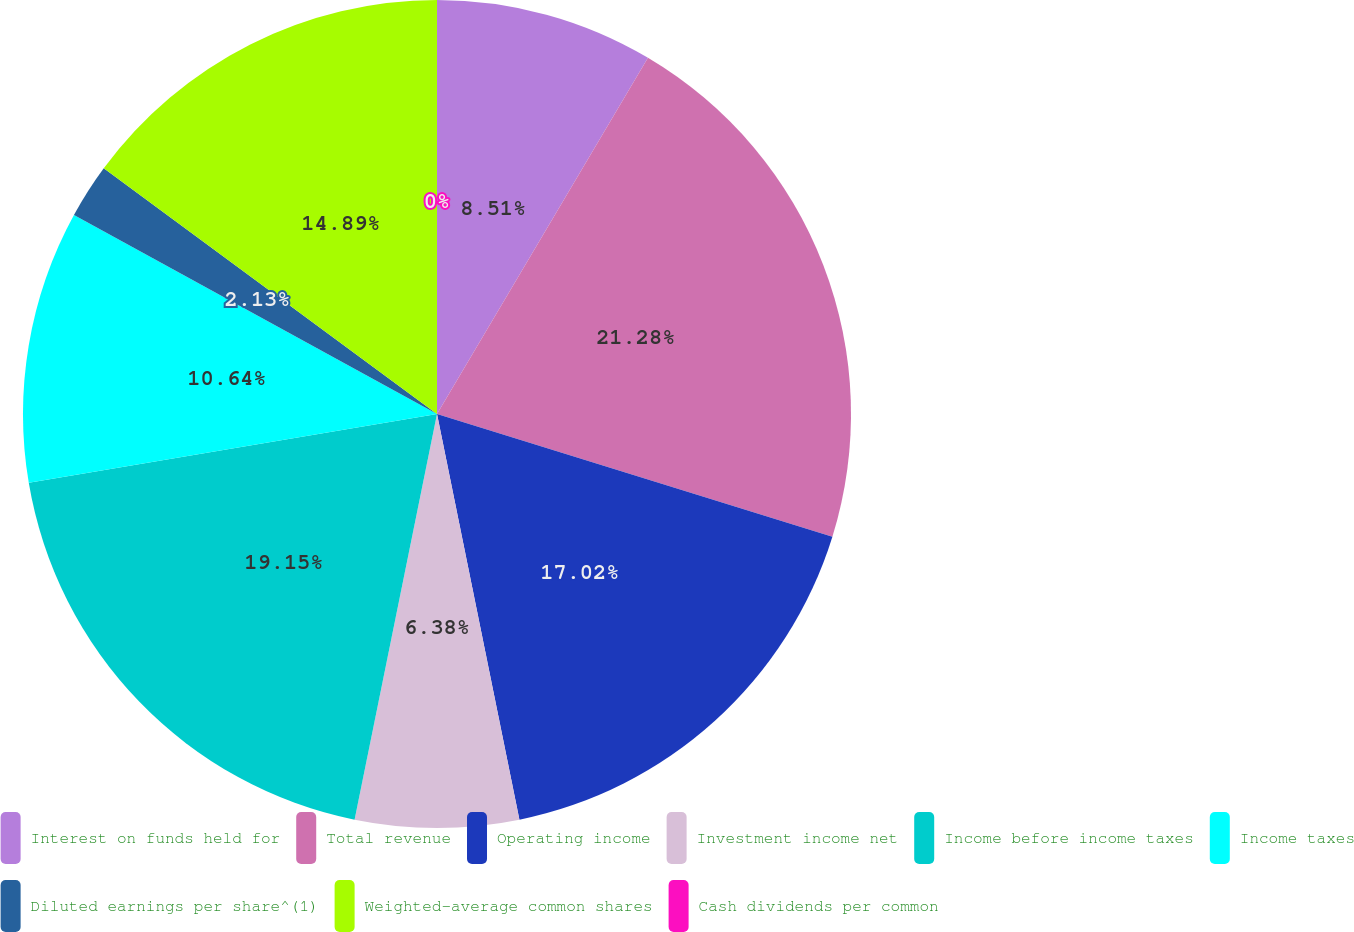<chart> <loc_0><loc_0><loc_500><loc_500><pie_chart><fcel>Interest on funds held for<fcel>Total revenue<fcel>Operating income<fcel>Investment income net<fcel>Income before income taxes<fcel>Income taxes<fcel>Diluted earnings per share^(1)<fcel>Weighted-average common shares<fcel>Cash dividends per common<nl><fcel>8.51%<fcel>21.28%<fcel>17.02%<fcel>6.38%<fcel>19.15%<fcel>10.64%<fcel>2.13%<fcel>14.89%<fcel>0.0%<nl></chart> 